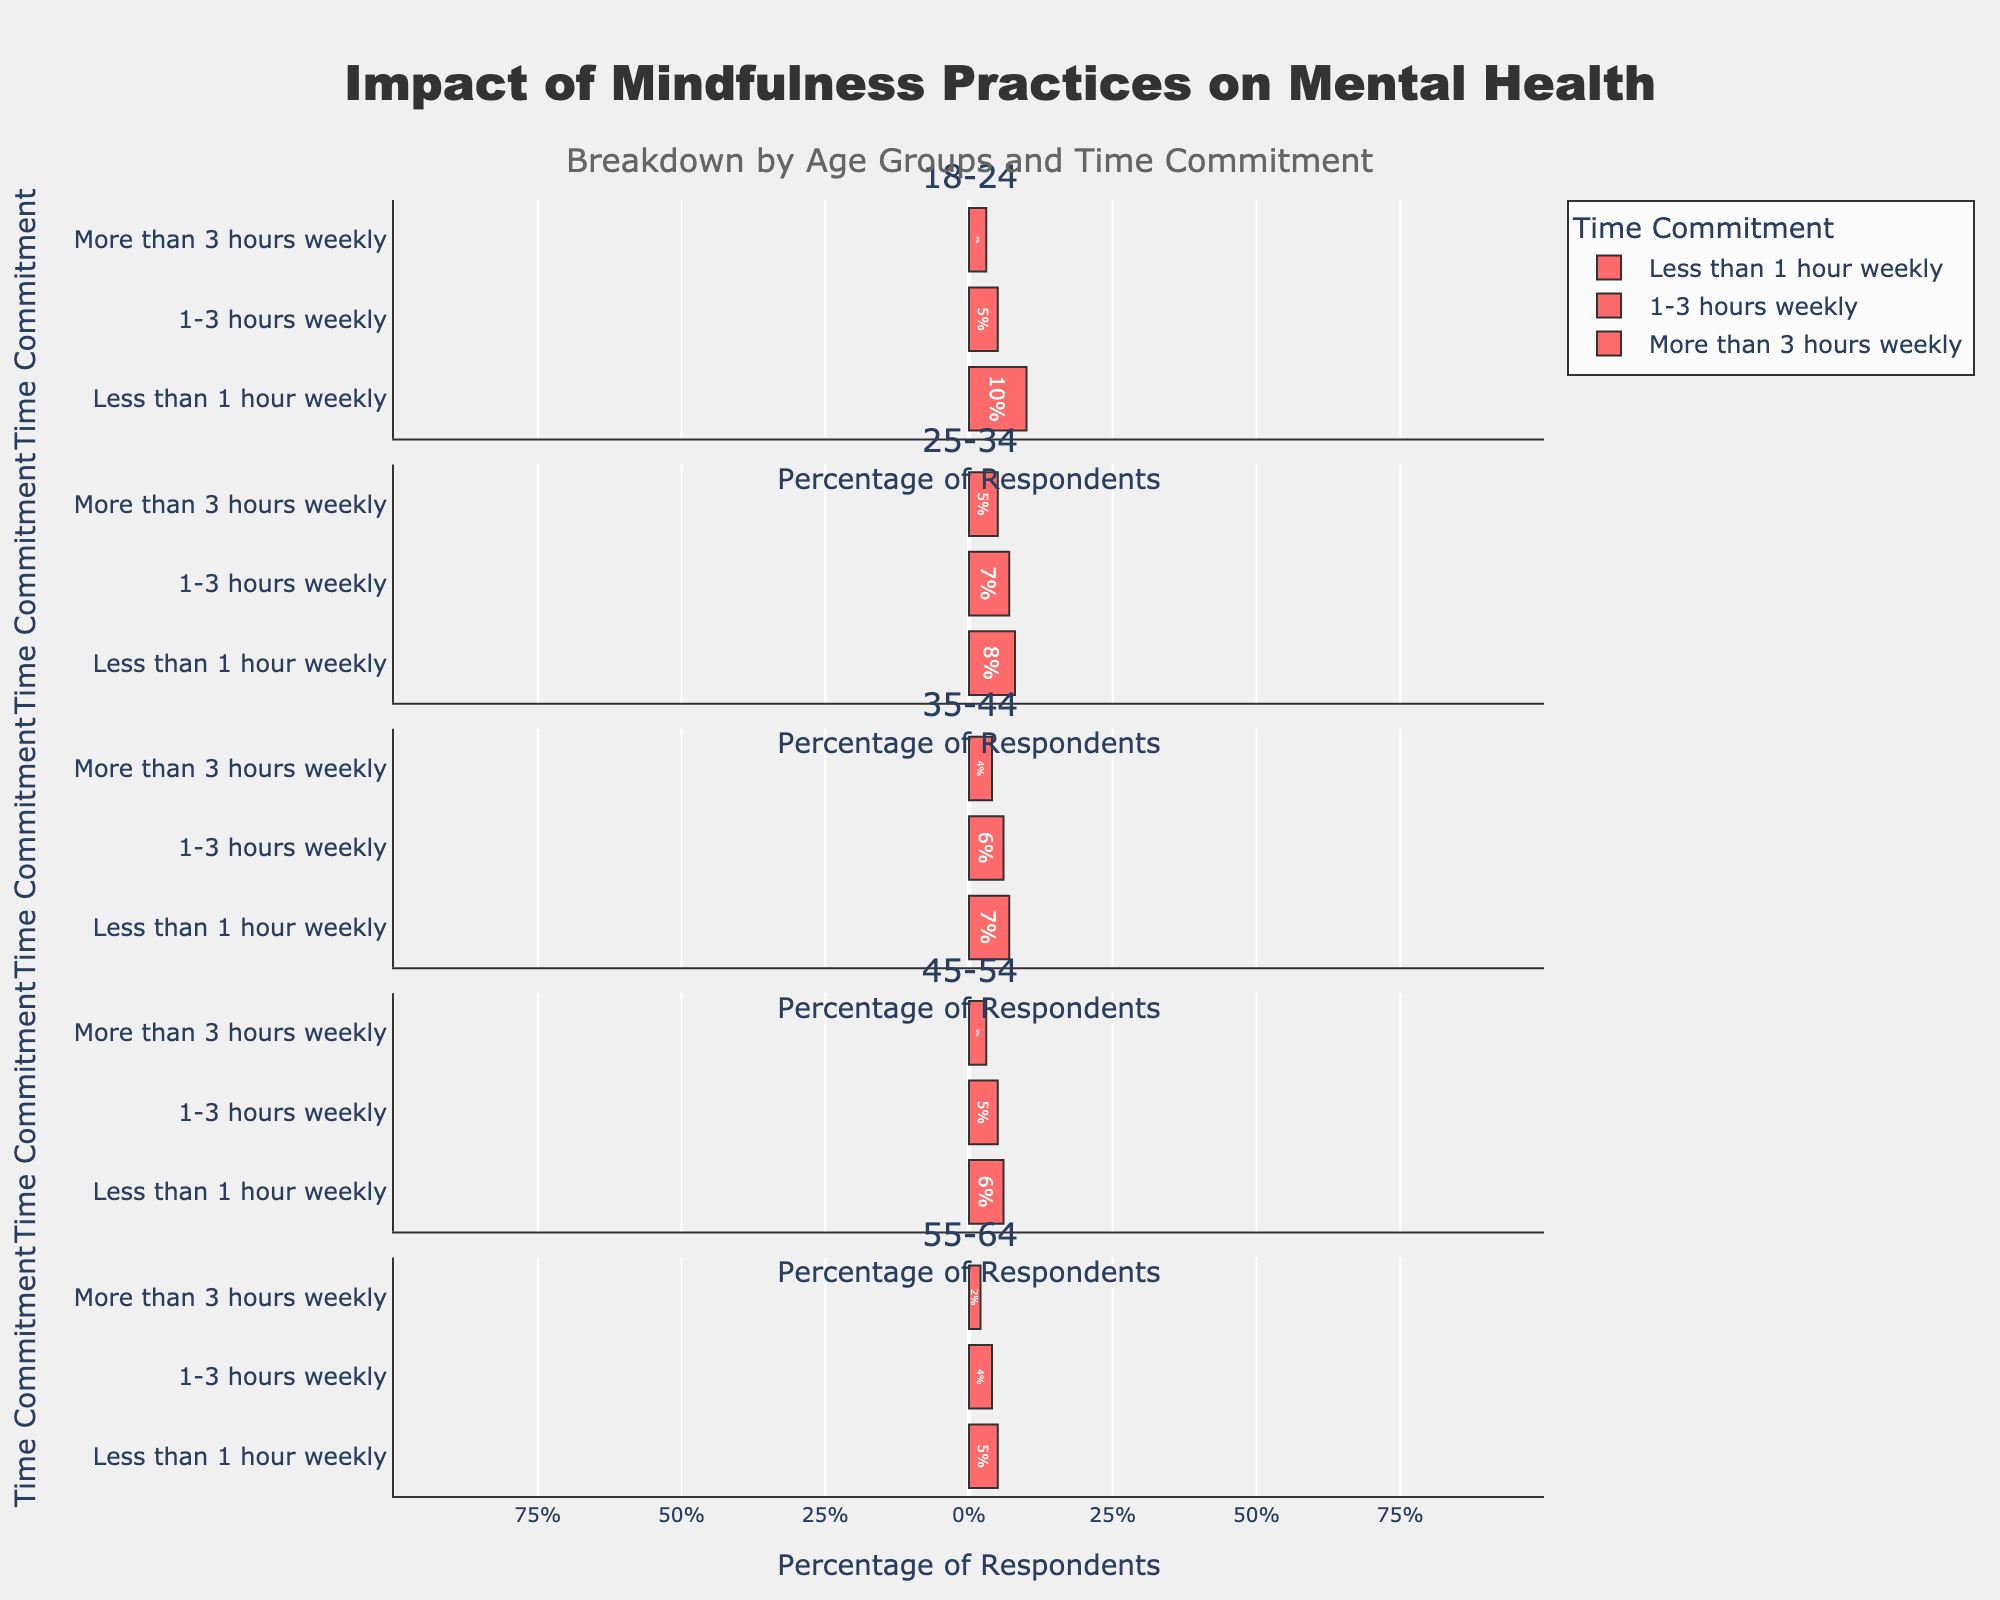Which age group shows the highest percentage of respondents with significant improvement when practicing mindfulness for more than 3 hours weekly? To determine this, look at the "Significant Improvement" section for the "More than 3 hours weekly" commitment across all age groups. Compare the percentages: 18-24 has 30%, 25-34 has 35%, 35-44 has 38%, 45-54 has 39%, and 55-64 has 30%.
Answer: 45-54 In the 25-34 age group, how does the percentage of respondents with moderate improvement compare between those practicing less than 1 hour weekly and more than 3 hours weekly? Check the percentages for "Moderate Improvement" in the 25-34 group: Less than 1 hour weekly is 12%, and More than 3 hours weekly is 15%. Compare them: 12% vs. 15%, so more than 3 hours weekly is higher.
Answer: More than 3 hours weekly is higher For respondents aged 35-44, which time commitment category shows the smallest percentage of minimal improvement? Look at the "Minimal Improvement" percentages for the 35-44 age group: Less than 1 hour weekly (7%), 1-3 hours weekly (6%), and More than 3 hours weekly (4%). The smallest percentage is for More than 3 hours weekly.
Answer: More than 3 hours weekly How does the percentage of respondents with significant improvement in the 45-54 age group for practicing more than 3 hours weekly compare to the 18-24 age group for the same time commitment? Compare the "Significant Improvement" percentages for the "More than 3 hours weekly" time commitment in both age groups: 45-54 has 39%, while 18-24 has 30%. As 39% is greater than 30%, the 45-54 group has a higher percentage.
Answer: 45-54 age group is higher In the 55-64 age group, what is the total percentage of respondents showing any improvement when practicing 1-3 hours weekly? Look at the "Minimal Improvement", "Moderate Improvement", and "Significant Improvement" percentages for 55-64 practicing 1-3 hours weekly. Sum them: 4% + 12% + 15% = 31%.
Answer: 31% Comparing the age groups 25-34 and 35-44, which shows a higher percentage of moderate improvement for practicing 1-3 hours weekly? Check the "Moderate Improvement" percentages for practicing 1-3 hours weekly: 25-34 has 18%, and 35-44 has 15%. Therefore, 25-34 is higher.
Answer: 25-34 Among the 18-24 age group, what is the difference in the percentage of respondents showing significant improvement between those practicing less than 1 hour weekly and those practicing more than 3 hours weekly? Note the significant improvement percentages for 18-24: Less than 1 hour weekly is 5%, and More than 3 hours weekly is 30%. The difference is 30% - 5% = 25%.
Answer: 25% For the age group 35-44, what is the average percentage of respondents showing significant improvement across all time commitments? Calculate significant improvement percentages for 35-44: Less than 1 hour weekly (8%), 1-3 hours weekly (22%), and More than 3 hours weekly (38%). Find the average: (8% + 22% + 38%) / 3 ≈ 22.67%.
Answer: 22.67% In the 45-54 group, how does the percentage of respondents with minimal improvement for those practicing less than 1 hour weekly compare to those practicing more than 3 hours weekly? Identify the minimal improvement percentages for 45-54: Less than 1 hour weekly (6%) and More than 3 hours weekly (3%). Compare: 6% is greater than 3%.
Answer: Less than 1 hour weekly is higher Which age group has the lowest percentage of respondents showing any improvement when practicing less than 1 hour weekly? Sum the percentages of minimal, moderate, and significant improvement for the "Less than 1 hour weekly" commitment across each age group. The age group with the lowest total is 55-64: 5% (minimal) + 8% (moderate) + 6% (significant) = 19%.
Answer: 55-64 